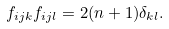<formula> <loc_0><loc_0><loc_500><loc_500>f _ { i j k } f _ { i j l } = 2 ( n + 1 ) \delta _ { k l } .</formula> 